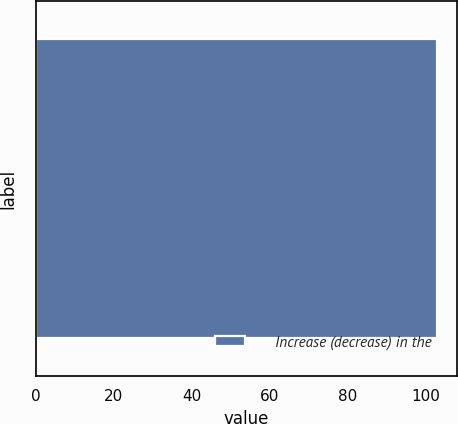<chart> <loc_0><loc_0><loc_500><loc_500><bar_chart><fcel>Increase (decrease) in the<nl><fcel>103<nl></chart> 